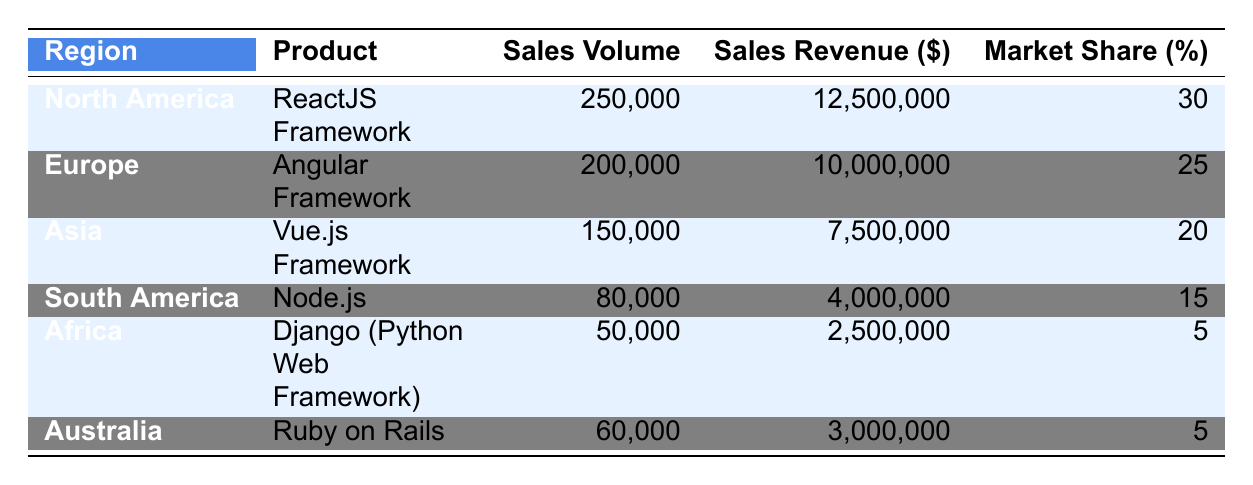What's the total sales revenue for web technology products in North America? From the table, the sales revenue for the ReactJS Framework in North America is 12,500,000. Since there is only one product listed for that region, the total sales revenue is the same as the individual sales revenue.
Answer: 12,500,000 Which region has the highest market share? Reviewing the market share values in the table, North America has a market share of 30, which is higher than all other regions. None of the other regions reach this value.
Answer: North America What is the average sales volume of web technology products across all regions? To find the average, sum all sales volumes: 250,000 (North America) + 200,000 (Europe) + 150,000 (Asia) + 80,000 (South America) + 50,000 (Africa) + 60,000 (Australia) = 790,000. Then, divide by the number of regions, which is 6: 790,000 / 6 = 131,666.67. Thus, the average is approximately 131,667 when rounded.
Answer: 131,667 Is the sales volume for Angular Framework greater than that of Vue.js Framework? The sales volume for Angular Framework (200,000) is greater than the sales volume for Vue.js Framework (150,000) as per the values in the table.
Answer: Yes What is the difference in sales revenue between the top two regions? The top two regions are North America with sales revenue of 12,500,000 and Europe with sales revenue of 10,000,000. To find the difference, subtract the revenue of Europe from that of North America: 12,500,000 - 10,000,000 = 2,500,000.
Answer: 2,500,000 Does Asia have the lowest sales volume among all regions? Looking at the sales volumes, Asia has a sales volume of 150,000, which is higher than South America (80,000), Africa (50,000), and Australia (60,000). Thus, Asia does not have the lowest sales volume.
Answer: No What percentage of the total sales revenue comes from the sales in South America? The total sales revenue across all regions is 12,500,000 (North America) + 10,000,000 (Europe) + 7,500,000 (Asia) + 4,000,000 (South America) + 2,500,000 (Africa) + 3,000,000 (Australia) = 39,000,000. South America's sales revenue is 4,000,000. To find the percentage: (4,000,000 / 39,000,000) * 100 = 10.26%.
Answer: 10.26% Which web technology product has the lowest sales volume? From the table, the sales volumes are: 250,000 (ReactJS), 200,000 (Angular), 150,000 (Vue.js), 80,000 (Node.js), 50,000 (Django), and 60,000 (Ruby on Rails). The lowest sales volume is 50,000 for Django.
Answer: Django (Python Web Framework) What is the total market share represented by the web technology products in Africa and Australia combined? The market share of Africa (5) and Australia (5) can be added together: 5 + 5 = 10.
Answer: 10 